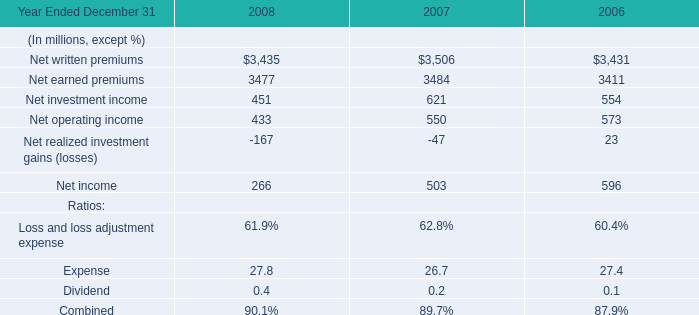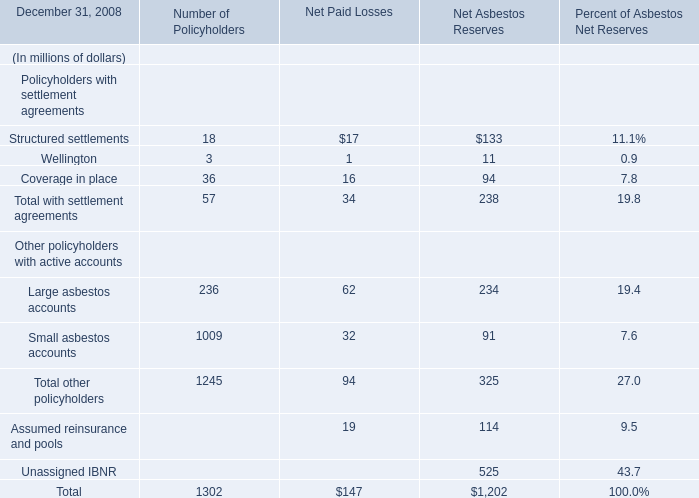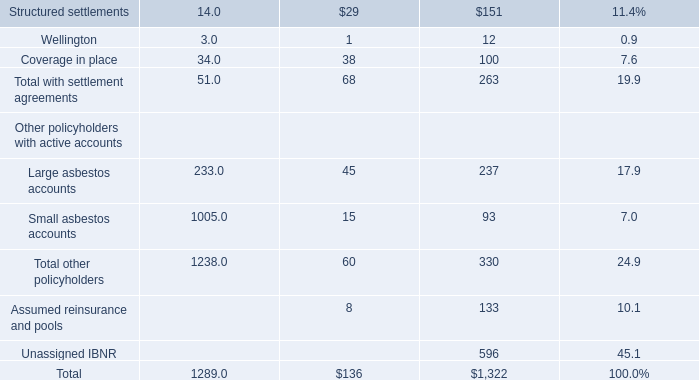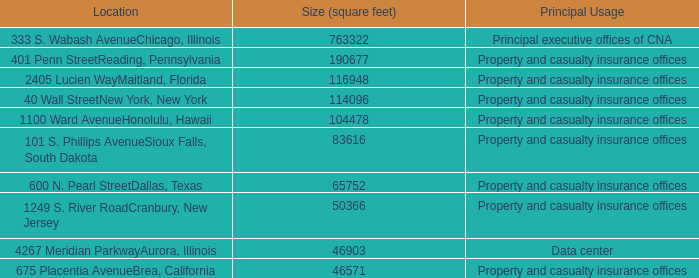What's the total value of all elements that are smaller than 100 for Number of Policyholders? (in million) 
Computations: ((18 + 3) + 36)
Answer: 57.0. 